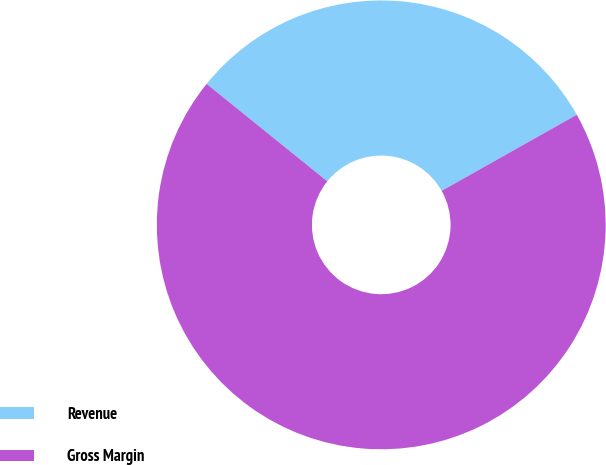Convert chart to OTSL. <chart><loc_0><loc_0><loc_500><loc_500><pie_chart><fcel>Revenue<fcel>Gross Margin<nl><fcel>31.03%<fcel>68.97%<nl></chart> 